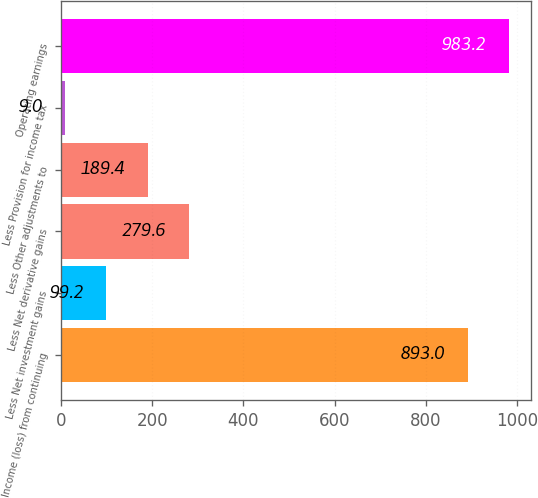Convert chart to OTSL. <chart><loc_0><loc_0><loc_500><loc_500><bar_chart><fcel>Income (loss) from continuing<fcel>Less Net investment gains<fcel>Less Net derivative gains<fcel>Less Other adjustments to<fcel>Less Provision for income tax<fcel>Operating earnings<nl><fcel>893<fcel>99.2<fcel>279.6<fcel>189.4<fcel>9<fcel>983.2<nl></chart> 